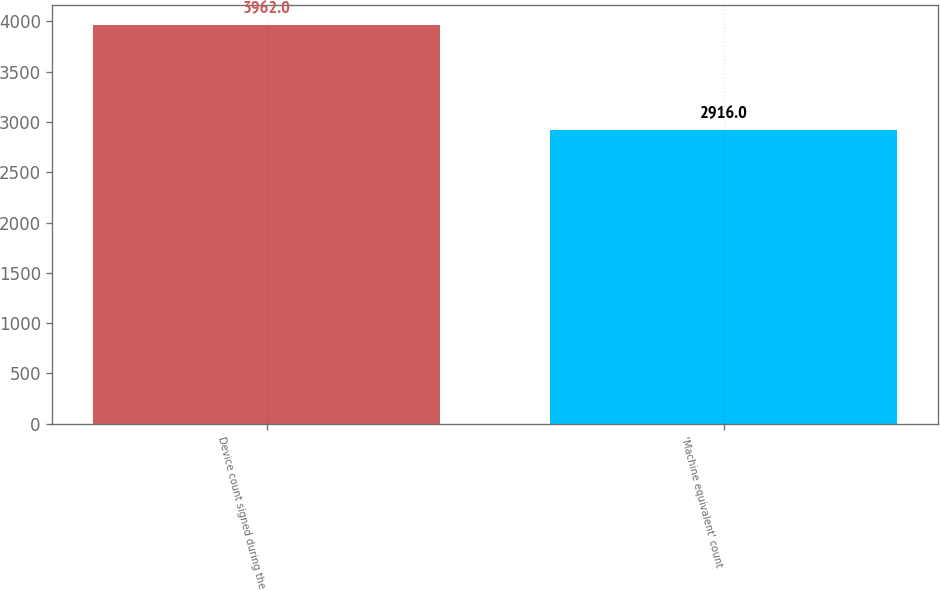Convert chart. <chart><loc_0><loc_0><loc_500><loc_500><bar_chart><fcel>Device count signed during the<fcel>'Machine equivalent' count<nl><fcel>3962<fcel>2916<nl></chart> 